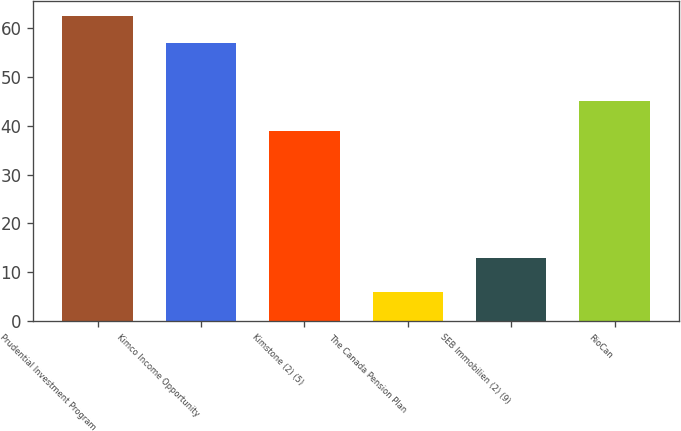Convert chart to OTSL. <chart><loc_0><loc_0><loc_500><loc_500><bar_chart><fcel>Prudential Investment Program<fcel>Kimco Income Opportunity<fcel>Kimstone (2) (5)<fcel>The Canada Pension Plan<fcel>SEB Immobilien (2) (9)<fcel>RioCan<nl><fcel>62.4<fcel>57<fcel>39<fcel>6<fcel>13<fcel>45<nl></chart> 